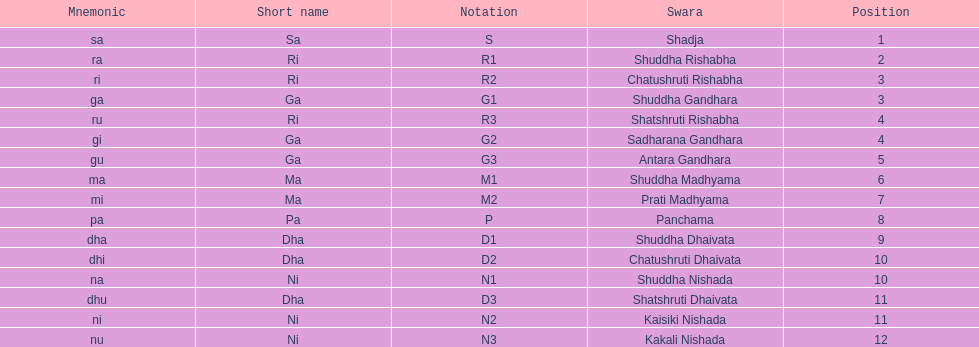List each pair of swaras that share the same position. Chatushruti Rishabha, Shuddha Gandhara, Shatshruti Rishabha, Sadharana Gandhara, Chatushruti Dhaivata, Shuddha Nishada, Shatshruti Dhaivata, Kaisiki Nishada. 